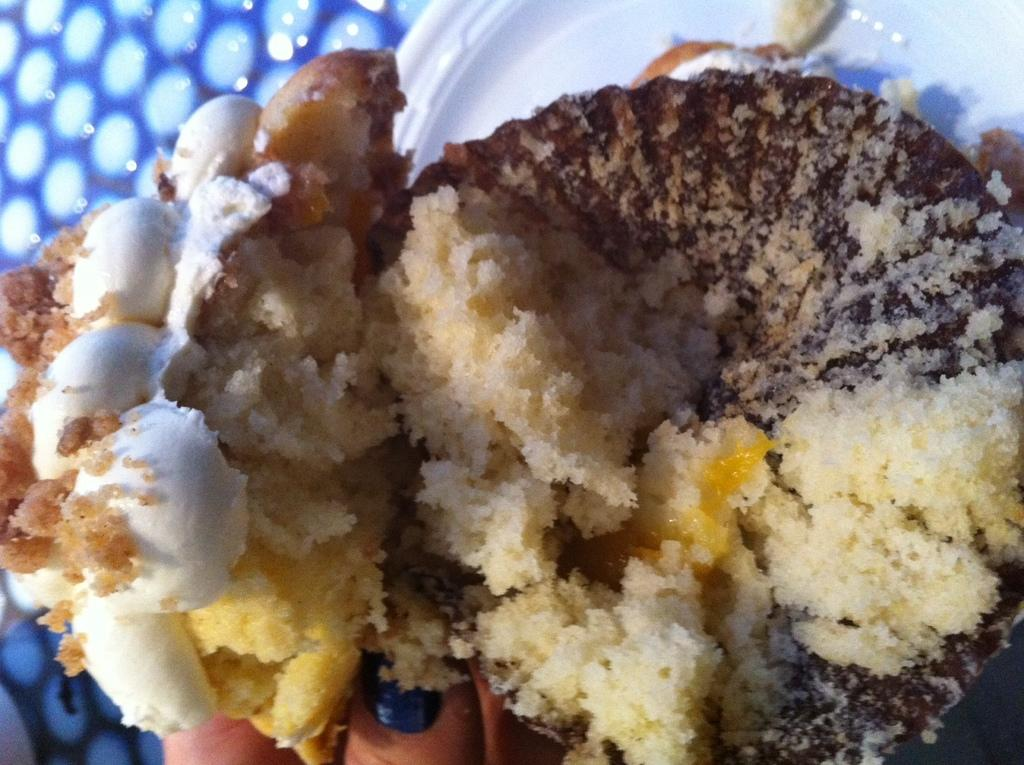What is on the plate in the image? There is food on a white color plate in the image. Can you describe any other details about the person's hands in the image? A person's fingers are visible in the image. What color can be seen on the left side of the image? The left side of the image has a blue color. What type of straw is being used to eat the food in the image? There is no straw present in the image; the person's fingers are visible instead. 